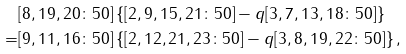Convert formula to latex. <formula><loc_0><loc_0><loc_500><loc_500>& [ 8 , 1 9 , 2 0 \colon 5 0 ] \left \{ [ 2 , 9 , 1 5 , 2 1 \colon 5 0 ] - q [ 3 , 7 , 1 3 , 1 8 \colon 5 0 ] \right \} \\ = & [ 9 , 1 1 , 1 6 \colon 5 0 ] \left \{ [ 2 , 1 2 , 2 1 , 2 3 \colon 5 0 ] - q [ 3 , 8 , 1 9 , 2 2 \colon 5 0 ] \right \} ,</formula> 